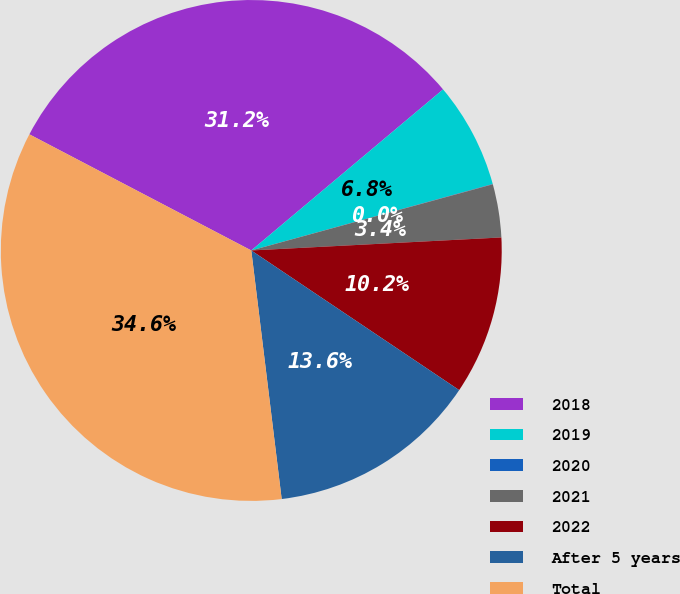Convert chart. <chart><loc_0><loc_0><loc_500><loc_500><pie_chart><fcel>2018<fcel>2019<fcel>2020<fcel>2021<fcel>2022<fcel>After 5 years<fcel>Total<nl><fcel>31.21%<fcel>6.84%<fcel>0.02%<fcel>3.43%<fcel>10.24%<fcel>13.65%<fcel>34.61%<nl></chart> 